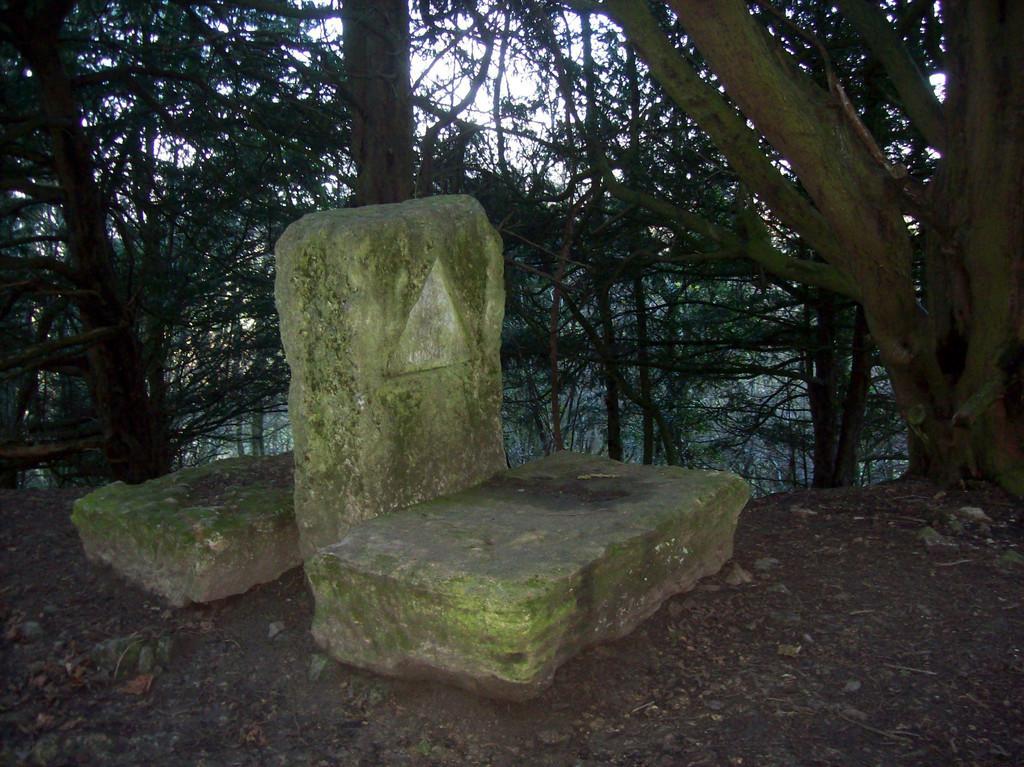Please provide a concise description of this image. There are three stones. On one stone there is a triangular shape. In the back there are trees. 